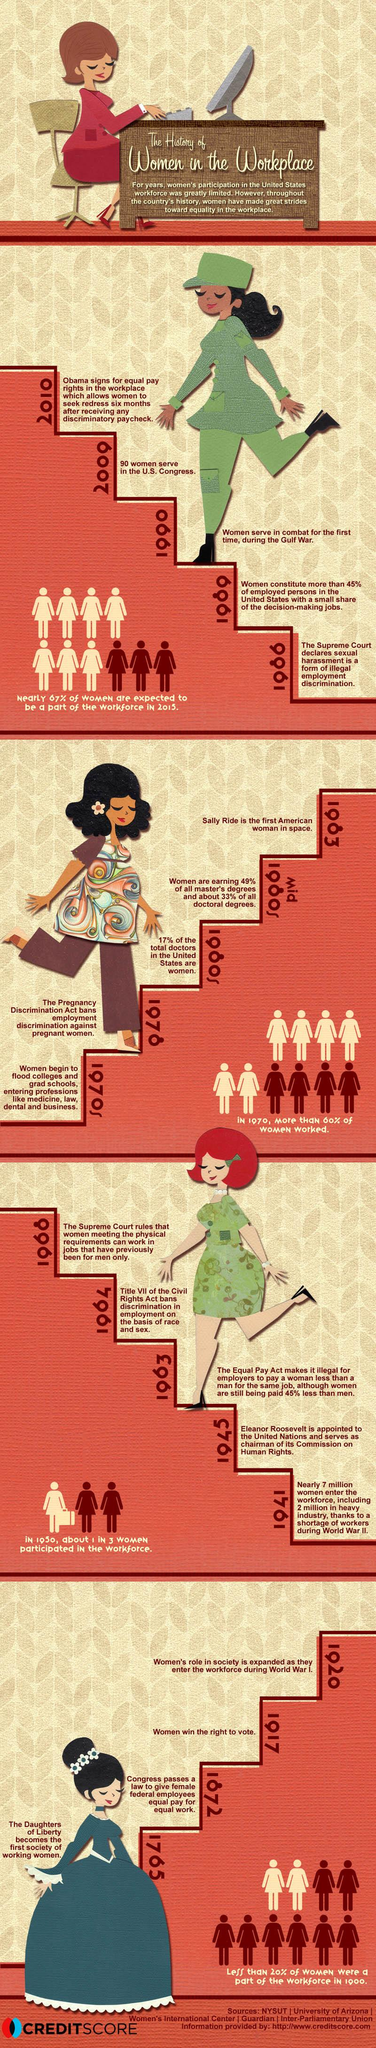Indicate a few pertinent items in this graphic. In 1917, women in the United States gained the right to vote. The United States' women served in combat for the first time during the Gulf War in 1990. 